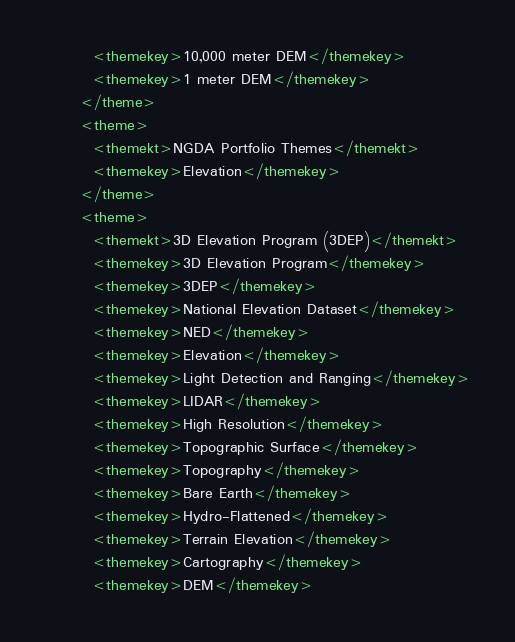Convert code to text. <code><loc_0><loc_0><loc_500><loc_500><_XML_>        <themekey>10,000 meter DEM</themekey>
        <themekey>1 meter DEM</themekey>
      </theme>
      <theme>
        <themekt>NGDA Portfolio Themes</themekt>
        <themekey>Elevation</themekey>
      </theme>
      <theme>
        <themekt>3D Elevation Program (3DEP)</themekt>
        <themekey>3D Elevation Program</themekey>
        <themekey>3DEP</themekey>
        <themekey>National Elevation Dataset</themekey>
        <themekey>NED</themekey>
        <themekey>Elevation</themekey>
        <themekey>Light Detection and Ranging</themekey>
        <themekey>LIDAR</themekey>
        <themekey>High Resolution</themekey>
        <themekey>Topographic Surface</themekey>
        <themekey>Topography</themekey>
        <themekey>Bare Earth</themekey>
        <themekey>Hydro-Flattened</themekey>
        <themekey>Terrain Elevation</themekey>
        <themekey>Cartography</themekey>
        <themekey>DEM</themekey></code> 